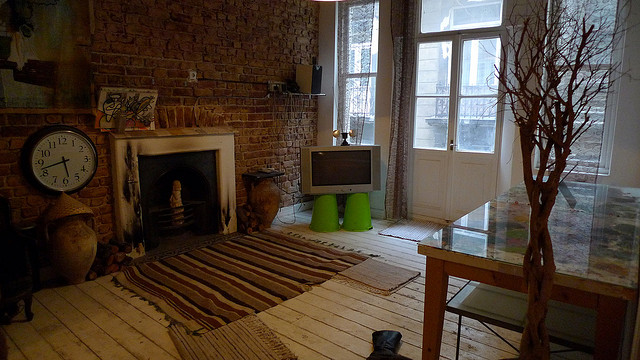<image>What pattern is the floor? I don't know exactly what pattern the floor has. It can be either lines, stripes or wood. Where are the bikes? There are no bikes visible in the image. However, if present, they could be outside. What type of skin is on the wall? There is no skin on the wall. It could be made of bricks. What pattern is the floor? It is ambiguous what pattern the floor has. It can be seen as either lines or stripes. Where are the bikes? It is unknown where the bikes are. There are no bikes shown in the image. What type of skin is on the wall? It is ambiguous what type of skin is on the wall. It can be seen as bricks or animal skin. 